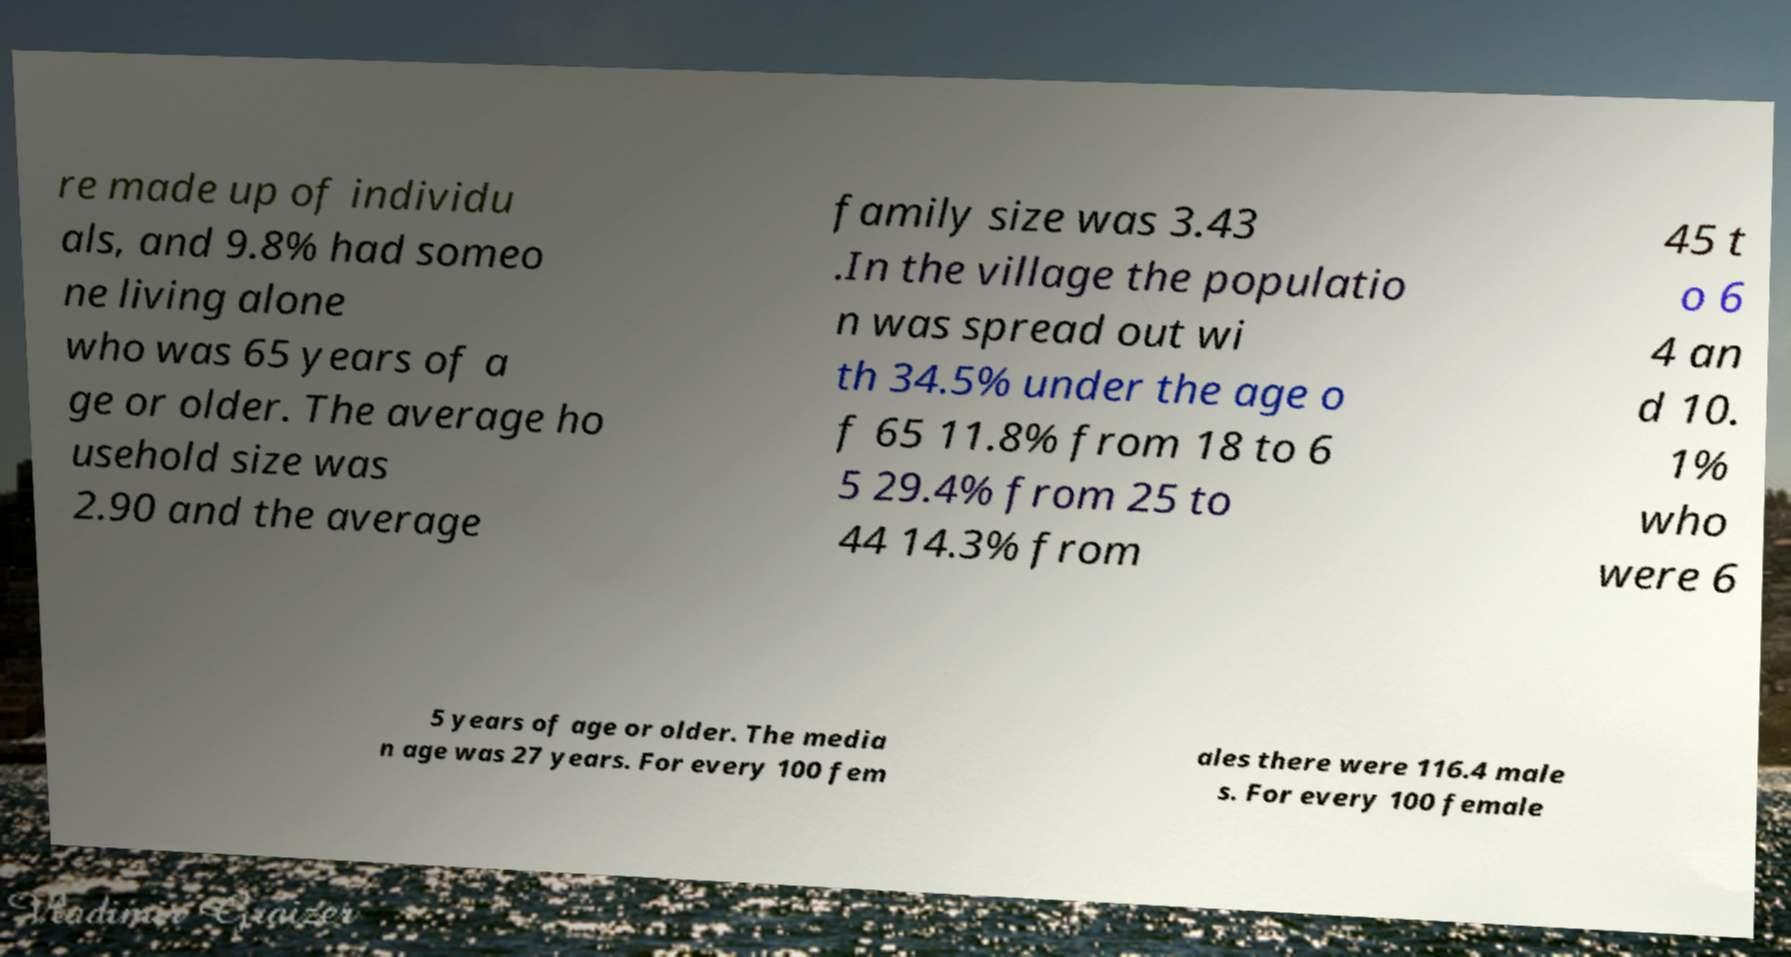Could you extract and type out the text from this image? re made up of individu als, and 9.8% had someo ne living alone who was 65 years of a ge or older. The average ho usehold size was 2.90 and the average family size was 3.43 .In the village the populatio n was spread out wi th 34.5% under the age o f 65 11.8% from 18 to 6 5 29.4% from 25 to 44 14.3% from 45 t o 6 4 an d 10. 1% who were 6 5 years of age or older. The media n age was 27 years. For every 100 fem ales there were 116.4 male s. For every 100 female 